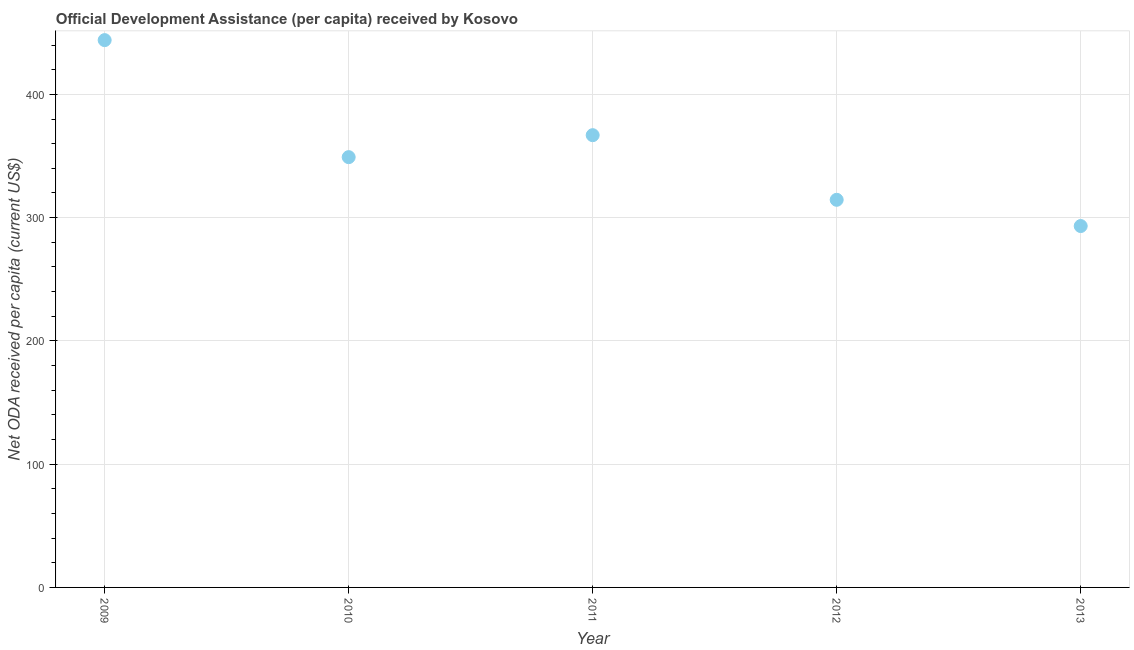What is the net oda received per capita in 2009?
Ensure brevity in your answer.  444.02. Across all years, what is the maximum net oda received per capita?
Keep it short and to the point. 444.02. Across all years, what is the minimum net oda received per capita?
Ensure brevity in your answer.  293.18. In which year was the net oda received per capita maximum?
Ensure brevity in your answer.  2009. In which year was the net oda received per capita minimum?
Provide a succinct answer. 2013. What is the sum of the net oda received per capita?
Ensure brevity in your answer.  1767.66. What is the difference between the net oda received per capita in 2009 and 2013?
Provide a succinct answer. 150.84. What is the average net oda received per capita per year?
Keep it short and to the point. 353.53. What is the median net oda received per capita?
Offer a terse response. 349.08. What is the ratio of the net oda received per capita in 2009 to that in 2013?
Your answer should be compact. 1.51. Is the net oda received per capita in 2009 less than that in 2012?
Provide a succinct answer. No. What is the difference between the highest and the second highest net oda received per capita?
Offer a terse response. 77.12. Is the sum of the net oda received per capita in 2011 and 2013 greater than the maximum net oda received per capita across all years?
Your answer should be very brief. Yes. What is the difference between the highest and the lowest net oda received per capita?
Offer a terse response. 150.84. In how many years, is the net oda received per capita greater than the average net oda received per capita taken over all years?
Offer a terse response. 2. How many dotlines are there?
Ensure brevity in your answer.  1. What is the difference between two consecutive major ticks on the Y-axis?
Your answer should be compact. 100. Are the values on the major ticks of Y-axis written in scientific E-notation?
Your answer should be very brief. No. Does the graph contain any zero values?
Provide a short and direct response. No. Does the graph contain grids?
Keep it short and to the point. Yes. What is the title of the graph?
Ensure brevity in your answer.  Official Development Assistance (per capita) received by Kosovo. What is the label or title of the Y-axis?
Give a very brief answer. Net ODA received per capita (current US$). What is the Net ODA received per capita (current US$) in 2009?
Keep it short and to the point. 444.02. What is the Net ODA received per capita (current US$) in 2010?
Offer a very short reply. 349.08. What is the Net ODA received per capita (current US$) in 2011?
Your response must be concise. 366.9. What is the Net ODA received per capita (current US$) in 2012?
Provide a succinct answer. 314.47. What is the Net ODA received per capita (current US$) in 2013?
Ensure brevity in your answer.  293.18. What is the difference between the Net ODA received per capita (current US$) in 2009 and 2010?
Your answer should be compact. 94.94. What is the difference between the Net ODA received per capita (current US$) in 2009 and 2011?
Your answer should be very brief. 77.12. What is the difference between the Net ODA received per capita (current US$) in 2009 and 2012?
Provide a succinct answer. 129.55. What is the difference between the Net ODA received per capita (current US$) in 2009 and 2013?
Your answer should be compact. 150.84. What is the difference between the Net ODA received per capita (current US$) in 2010 and 2011?
Your answer should be compact. -17.82. What is the difference between the Net ODA received per capita (current US$) in 2010 and 2012?
Make the answer very short. 34.61. What is the difference between the Net ODA received per capita (current US$) in 2010 and 2013?
Your answer should be compact. 55.9. What is the difference between the Net ODA received per capita (current US$) in 2011 and 2012?
Provide a succinct answer. 52.44. What is the difference between the Net ODA received per capita (current US$) in 2011 and 2013?
Provide a short and direct response. 73.72. What is the difference between the Net ODA received per capita (current US$) in 2012 and 2013?
Offer a terse response. 21.29. What is the ratio of the Net ODA received per capita (current US$) in 2009 to that in 2010?
Ensure brevity in your answer.  1.27. What is the ratio of the Net ODA received per capita (current US$) in 2009 to that in 2011?
Keep it short and to the point. 1.21. What is the ratio of the Net ODA received per capita (current US$) in 2009 to that in 2012?
Provide a succinct answer. 1.41. What is the ratio of the Net ODA received per capita (current US$) in 2009 to that in 2013?
Ensure brevity in your answer.  1.51. What is the ratio of the Net ODA received per capita (current US$) in 2010 to that in 2011?
Your answer should be compact. 0.95. What is the ratio of the Net ODA received per capita (current US$) in 2010 to that in 2012?
Your answer should be compact. 1.11. What is the ratio of the Net ODA received per capita (current US$) in 2010 to that in 2013?
Make the answer very short. 1.19. What is the ratio of the Net ODA received per capita (current US$) in 2011 to that in 2012?
Offer a very short reply. 1.17. What is the ratio of the Net ODA received per capita (current US$) in 2011 to that in 2013?
Give a very brief answer. 1.25. What is the ratio of the Net ODA received per capita (current US$) in 2012 to that in 2013?
Give a very brief answer. 1.07. 